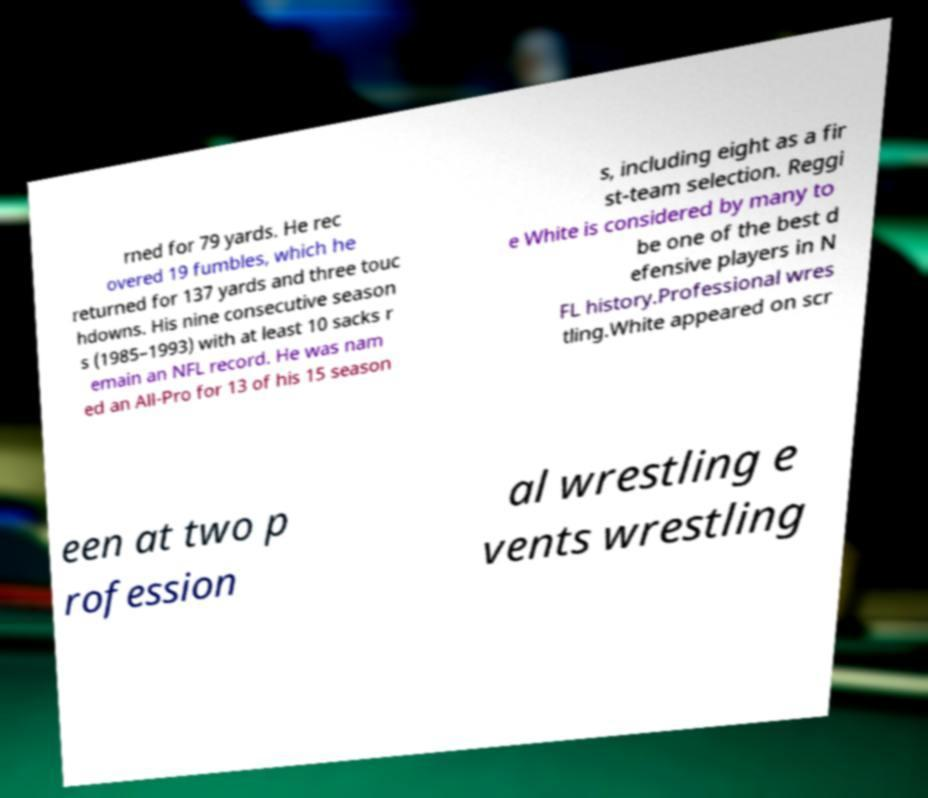What messages or text are displayed in this image? I need them in a readable, typed format. rned for 79 yards. He rec overed 19 fumbles, which he returned for 137 yards and three touc hdowns. His nine consecutive season s (1985–1993) with at least 10 sacks r emain an NFL record. He was nam ed an All-Pro for 13 of his 15 season s, including eight as a fir st-team selection. Reggi e White is considered by many to be one of the best d efensive players in N FL history.Professional wres tling.White appeared on scr een at two p rofession al wrestling e vents wrestling 